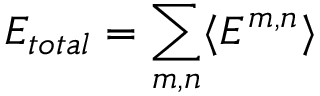<formula> <loc_0><loc_0><loc_500><loc_500>E _ { t o t a l } = \sum _ { m , n } \langle E ^ { m , n } \rangle</formula> 